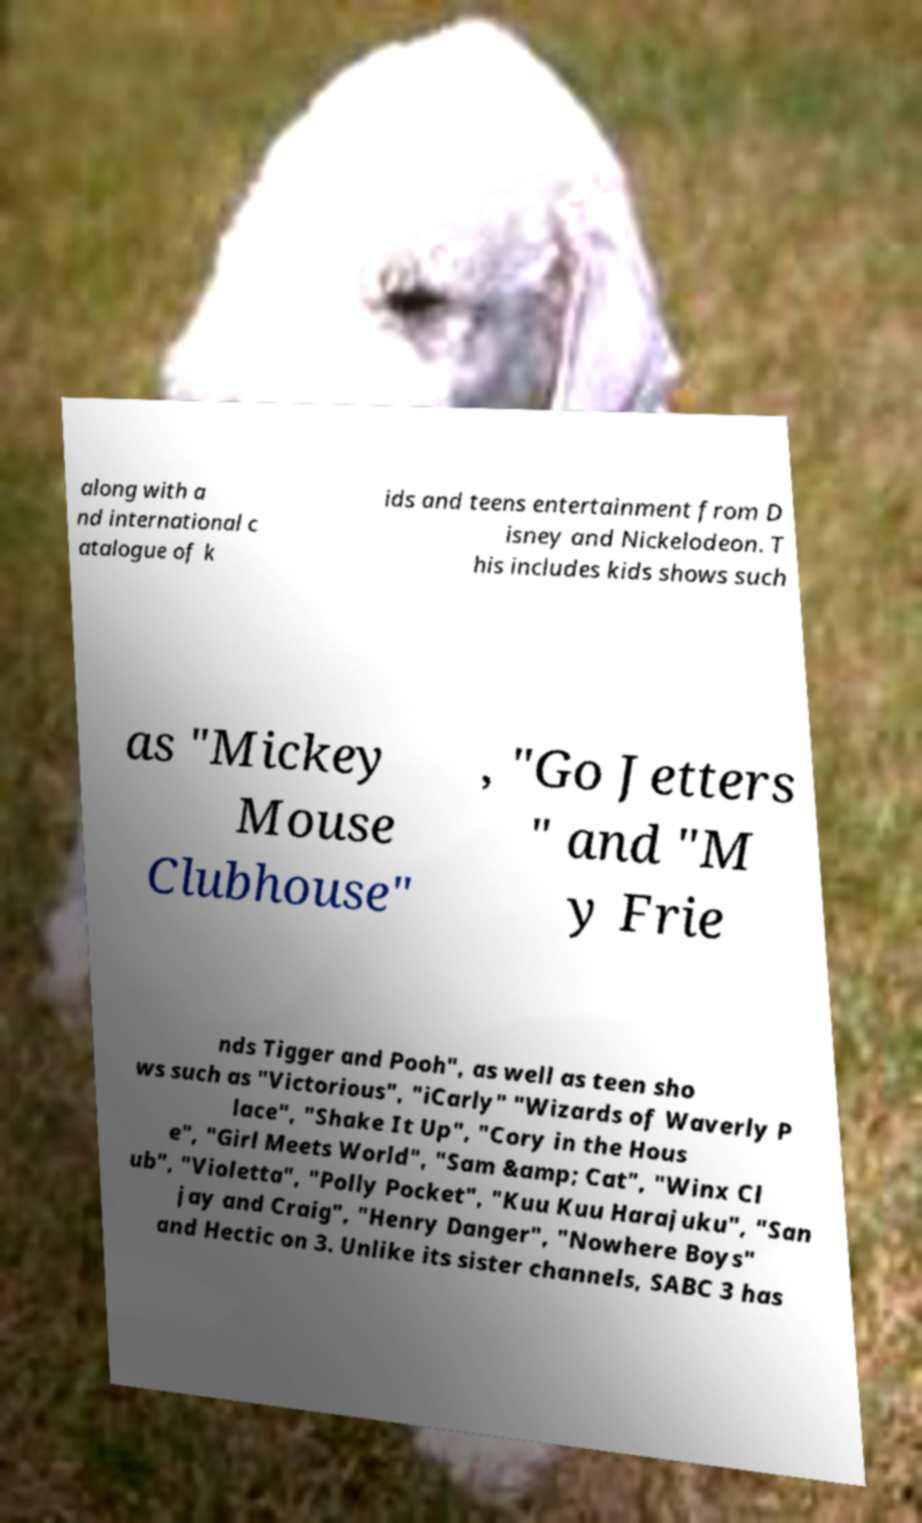Could you assist in decoding the text presented in this image and type it out clearly? along with a nd international c atalogue of k ids and teens entertainment from D isney and Nickelodeon. T his includes kids shows such as "Mickey Mouse Clubhouse" , "Go Jetters " and "M y Frie nds Tigger and Pooh", as well as teen sho ws such as "Victorious", "iCarly" "Wizards of Waverly P lace", "Shake It Up", "Cory in the Hous e", "Girl Meets World", "Sam &amp; Cat", "Winx Cl ub", "Violetta", "Polly Pocket", "Kuu Kuu Harajuku", "San jay and Craig", "Henry Danger", "Nowhere Boys" and Hectic on 3. Unlike its sister channels, SABC 3 has 